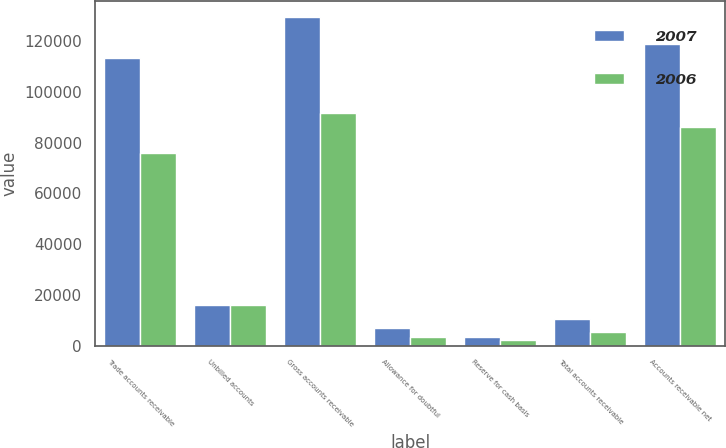<chart> <loc_0><loc_0><loc_500><loc_500><stacked_bar_chart><ecel><fcel>Trade accounts receivable<fcel>Unbilled accounts<fcel>Gross accounts receivable<fcel>Allowance for doubtful<fcel>Reserve for cash basis<fcel>Total accounts receivable<fcel>Accounts receivable net<nl><fcel>2007<fcel>113357<fcel>15978<fcel>129335<fcel>6878<fcel>3513<fcel>10391<fcel>118944<nl><fcel>2006<fcel>75771<fcel>15929<fcel>91700<fcel>3228<fcel>2240<fcel>5468<fcel>86232<nl></chart> 